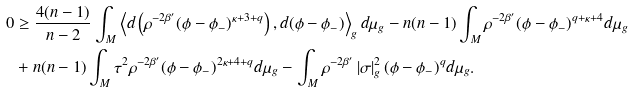<formula> <loc_0><loc_0><loc_500><loc_500>0 & \geq \frac { 4 ( n - 1 ) } { n - 2 } \int _ { M } \left \langle d \left ( \rho ^ { - 2 \beta ^ { \prime } } ( \phi - \phi _ { - } ) ^ { \kappa + 3 + q } \right ) , d ( \phi - \phi _ { - } ) \right \rangle _ { g } d \mu _ { g } - n ( n - 1 ) \int _ { M } \rho ^ { - 2 \beta ^ { \prime } } ( \phi - \phi _ { - } ) ^ { q + \kappa + 4 } d \mu _ { g } \\ & + n ( n - 1 ) \int _ { M } \tau ^ { 2 } \rho ^ { - 2 \beta ^ { \prime } } ( \phi - \phi _ { - } ) ^ { 2 \kappa + 4 + q } d \mu _ { g } - \int _ { M } \rho ^ { - 2 \beta ^ { \prime } } \left | \sigma \right | _ { g } ^ { 2 } ( \phi - \phi _ { - } ) ^ { q } d \mu _ { g } .</formula> 